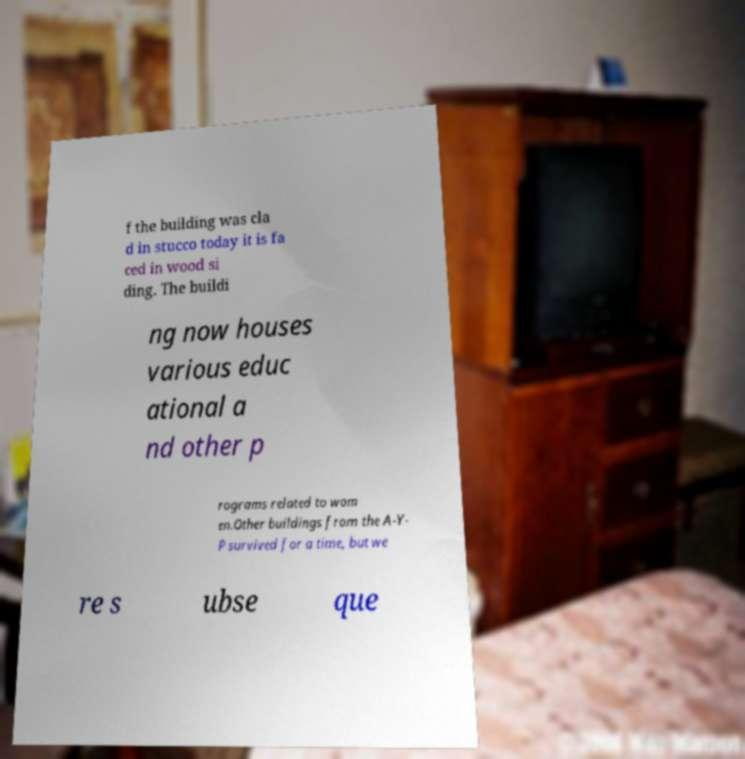Could you extract and type out the text from this image? f the building was cla d in stucco today it is fa ced in wood si ding. The buildi ng now houses various educ ational a nd other p rograms related to wom en.Other buildings from the A-Y- P survived for a time, but we re s ubse que 